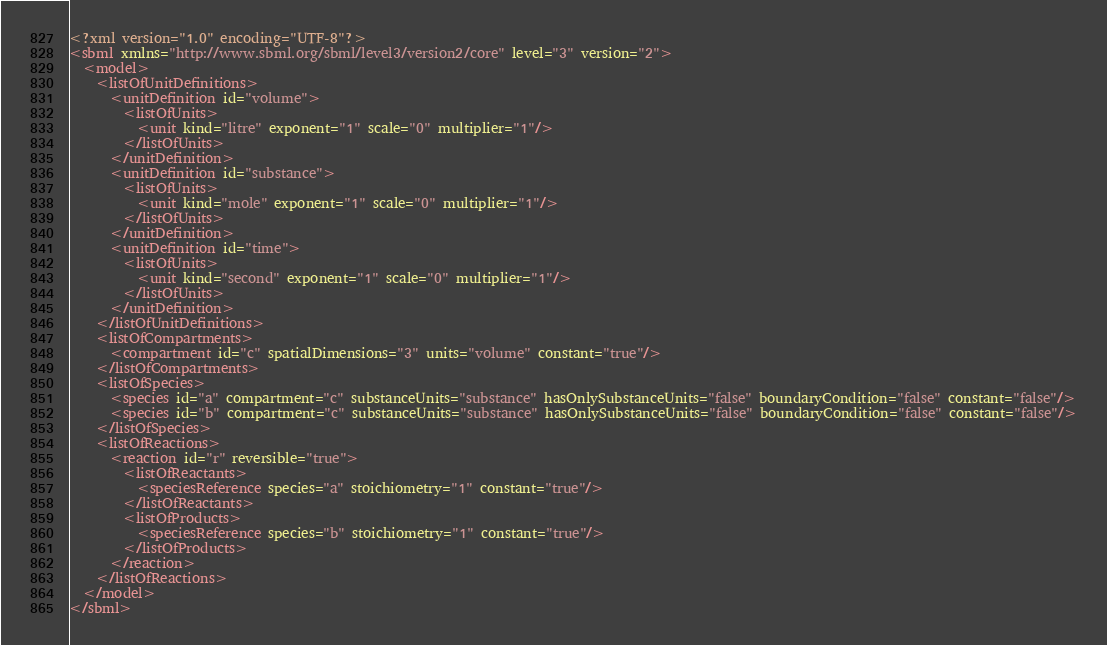<code> <loc_0><loc_0><loc_500><loc_500><_XML_><?xml version="1.0" encoding="UTF-8"?>
<sbml xmlns="http://www.sbml.org/sbml/level3/version2/core" level="3" version="2">
  <model>
    <listOfUnitDefinitions>
      <unitDefinition id="volume">
        <listOfUnits>
          <unit kind="litre" exponent="1" scale="0" multiplier="1"/>
        </listOfUnits>
      </unitDefinition>
      <unitDefinition id="substance">
        <listOfUnits>
          <unit kind="mole" exponent="1" scale="0" multiplier="1"/>
        </listOfUnits>
      </unitDefinition>
      <unitDefinition id="time">
        <listOfUnits>
          <unit kind="second" exponent="1" scale="0" multiplier="1"/>
        </listOfUnits>
      </unitDefinition>
    </listOfUnitDefinitions>
    <listOfCompartments>
      <compartment id="c" spatialDimensions="3" units="volume" constant="true"/>
    </listOfCompartments>
    <listOfSpecies>
      <species id="a" compartment="c" substanceUnits="substance" hasOnlySubstanceUnits="false" boundaryCondition="false" constant="false"/>
      <species id="b" compartment="c" substanceUnits="substance" hasOnlySubstanceUnits="false" boundaryCondition="false" constant="false"/>
    </listOfSpecies>
    <listOfReactions>
      <reaction id="r" reversible="true">
        <listOfReactants>
          <speciesReference species="a" stoichiometry="1" constant="true"/>
        </listOfReactants>
        <listOfProducts>
          <speciesReference species="b" stoichiometry="1" constant="true"/>
        </listOfProducts>
      </reaction>
    </listOfReactions>
  </model>
</sbml>
</code> 